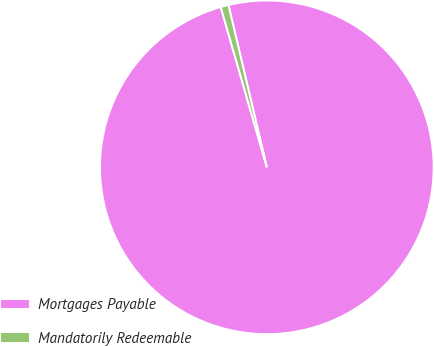Convert chart. <chart><loc_0><loc_0><loc_500><loc_500><pie_chart><fcel>Mortgages Payable<fcel>Mandatorily Redeemable<nl><fcel>99.24%<fcel>0.76%<nl></chart> 